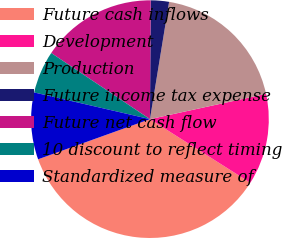<chart> <loc_0><loc_0><loc_500><loc_500><pie_chart><fcel>Future cash inflows<fcel>Development<fcel>Production<fcel>Future income tax expense<fcel>Future net cash flow<fcel>10 discount to reflect timing<fcel>Standardized measure of<nl><fcel>35.53%<fcel>12.4%<fcel>19.01%<fcel>2.48%<fcel>15.7%<fcel>5.79%<fcel>9.09%<nl></chart> 